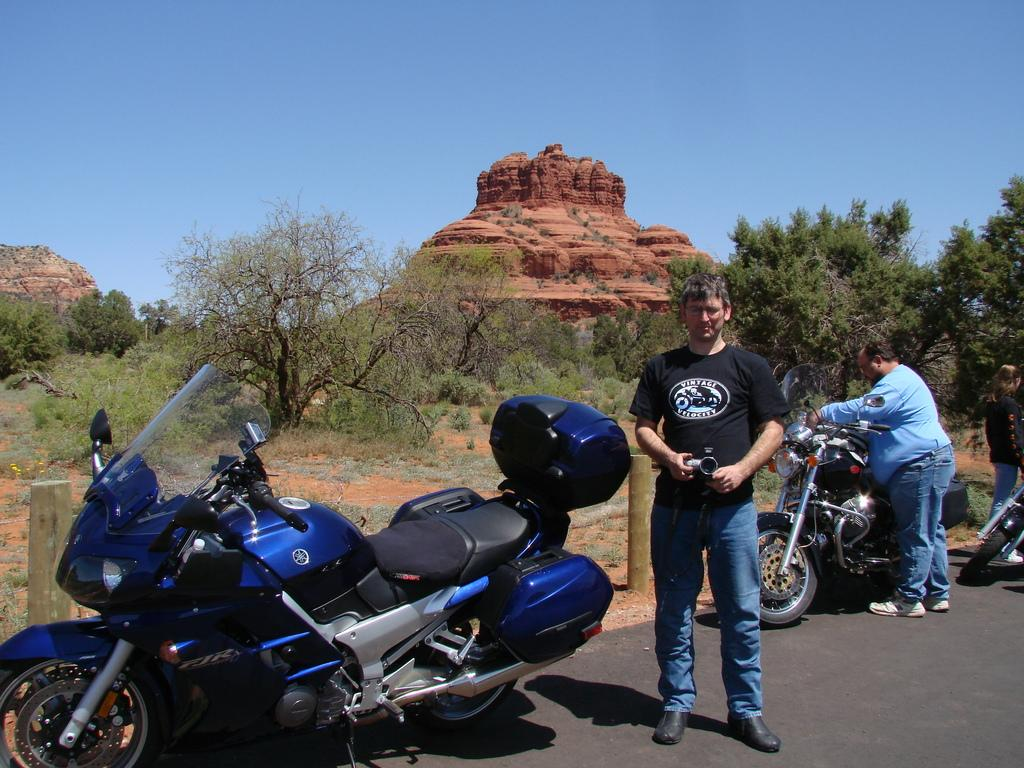What can be seen on the right side of the image? There are people and bikes on the right side of the image. What is located in the center of the image? There is a bike in the center of the image. What type of natural elements are visible in the background of the image? There are trees, stone structures, and the sky visible in the background of the image. What type of salt is being used to chain the bikes together in the image? There is no salt or chains present in the image; the bikes are not connected to each other. How does the digestion process of the people in the image affect the stone structures in the background? There is no information about the people's digestion process or its effect on the stone structures in the image. 